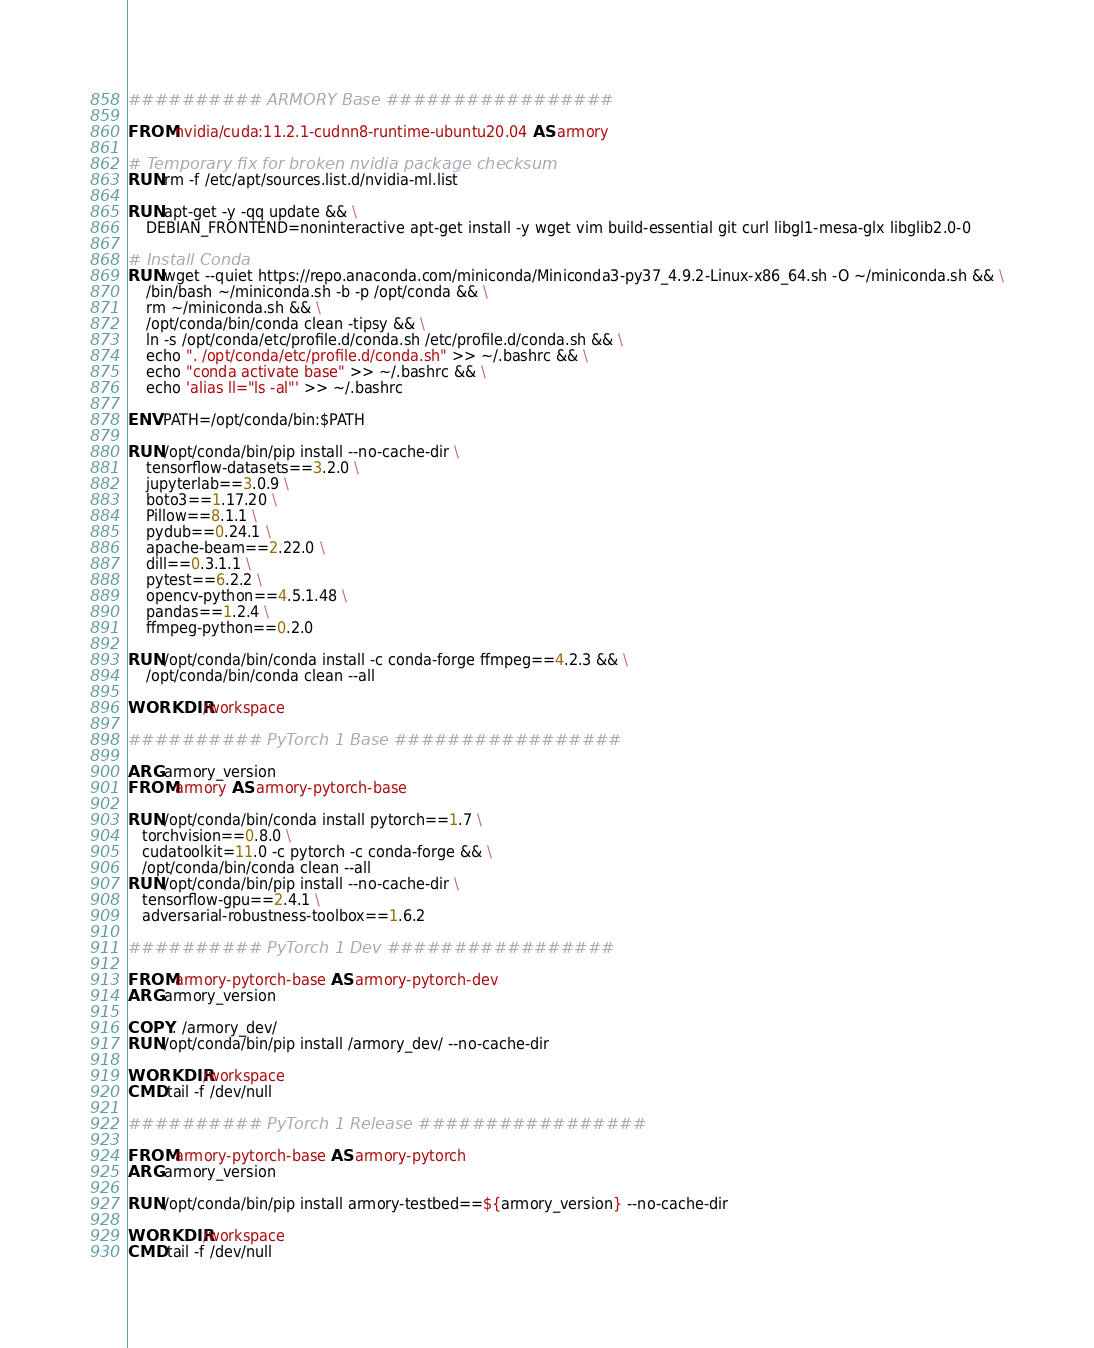<code> <loc_0><loc_0><loc_500><loc_500><_Dockerfile_>########## ARMORY Base #################

FROM nvidia/cuda:11.2.1-cudnn8-runtime-ubuntu20.04 AS armory

# Temporary fix for broken nvidia package checksum
RUN rm -f /etc/apt/sources.list.d/nvidia-ml.list

RUN apt-get -y -qq update && \
    DEBIAN_FRONTEND=noninteractive apt-get install -y wget vim build-essential git curl libgl1-mesa-glx libglib2.0-0

# Install Conda
RUN wget --quiet https://repo.anaconda.com/miniconda/Miniconda3-py37_4.9.2-Linux-x86_64.sh -O ~/miniconda.sh && \
    /bin/bash ~/miniconda.sh -b -p /opt/conda && \
    rm ~/miniconda.sh && \
    /opt/conda/bin/conda clean -tipsy && \
    ln -s /opt/conda/etc/profile.d/conda.sh /etc/profile.d/conda.sh && \
    echo ". /opt/conda/etc/profile.d/conda.sh" >> ~/.bashrc && \
    echo "conda activate base" >> ~/.bashrc && \
    echo 'alias ll="ls -al"' >> ~/.bashrc

ENV PATH=/opt/conda/bin:$PATH

RUN /opt/conda/bin/pip install --no-cache-dir \
    tensorflow-datasets==3.2.0 \
    jupyterlab==3.0.9 \
    boto3==1.17.20 \
    Pillow==8.1.1 \
    pydub==0.24.1 \
    apache-beam==2.22.0 \
    dill==0.3.1.1 \
    pytest==6.2.2 \
    opencv-python==4.5.1.48 \
    pandas==1.2.4 \
    ffmpeg-python==0.2.0

RUN /opt/conda/bin/conda install -c conda-forge ffmpeg==4.2.3 && \
    /opt/conda/bin/conda clean --all

WORKDIR /workspace

########## PyTorch 1 Base #################

ARG armory_version
FROM armory AS armory-pytorch-base

RUN /opt/conda/bin/conda install pytorch==1.7 \
   torchvision==0.8.0 \ 
   cudatoolkit=11.0 -c pytorch -c conda-forge && \
   /opt/conda/bin/conda clean --all
RUN /opt/conda/bin/pip install --no-cache-dir \
   tensorflow-gpu==2.4.1 \
   adversarial-robustness-toolbox==1.6.2

########## PyTorch 1 Dev #################

FROM armory-pytorch-base AS armory-pytorch-dev
ARG armory_version

COPY . /armory_dev/
RUN /opt/conda/bin/pip install /armory_dev/ --no-cache-dir 

WORKDIR /workspace
CMD tail -f /dev/null

########## PyTorch 1 Release #################

FROM armory-pytorch-base AS armory-pytorch
ARG armory_version

RUN /opt/conda/bin/pip install armory-testbed==${armory_version} --no-cache-dir

WORKDIR /workspace
CMD tail -f /dev/null
</code> 